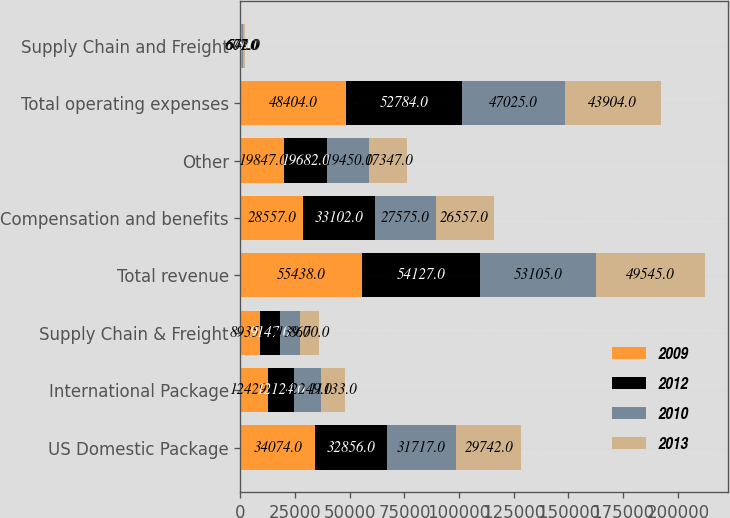Convert chart. <chart><loc_0><loc_0><loc_500><loc_500><stacked_bar_chart><ecel><fcel>US Domestic Package<fcel>International Package<fcel>Supply Chain & Freight<fcel>Total revenue<fcel>Compensation and benefits<fcel>Other<fcel>Total operating expenses<fcel>Supply Chain and Freight<nl><fcel>2009<fcel>34074<fcel>12429<fcel>8935<fcel>55438<fcel>28557<fcel>19847<fcel>48404<fcel>674<nl><fcel>2012<fcel>32856<fcel>12124<fcel>9147<fcel>54127<fcel>33102<fcel>19682<fcel>52784<fcel>15<nl><fcel>2010<fcel>31717<fcel>12249<fcel>9139<fcel>53105<fcel>27575<fcel>19450<fcel>47025<fcel>607<nl><fcel>2013<fcel>29742<fcel>11133<fcel>8670<fcel>49545<fcel>26557<fcel>17347<fcel>43904<fcel>572<nl></chart> 